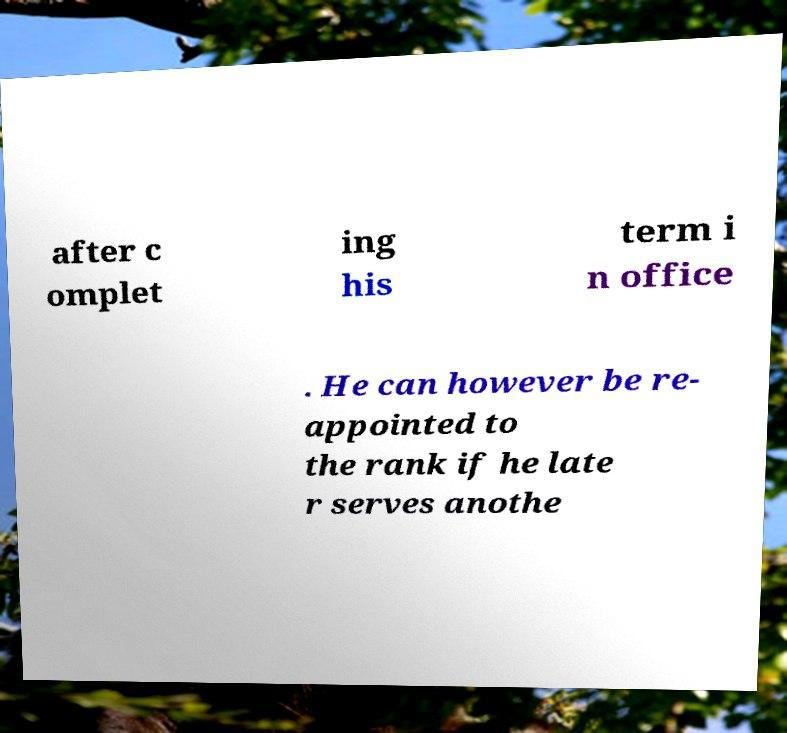Could you assist in decoding the text presented in this image and type it out clearly? after c omplet ing his term i n office . He can however be re- appointed to the rank if he late r serves anothe 